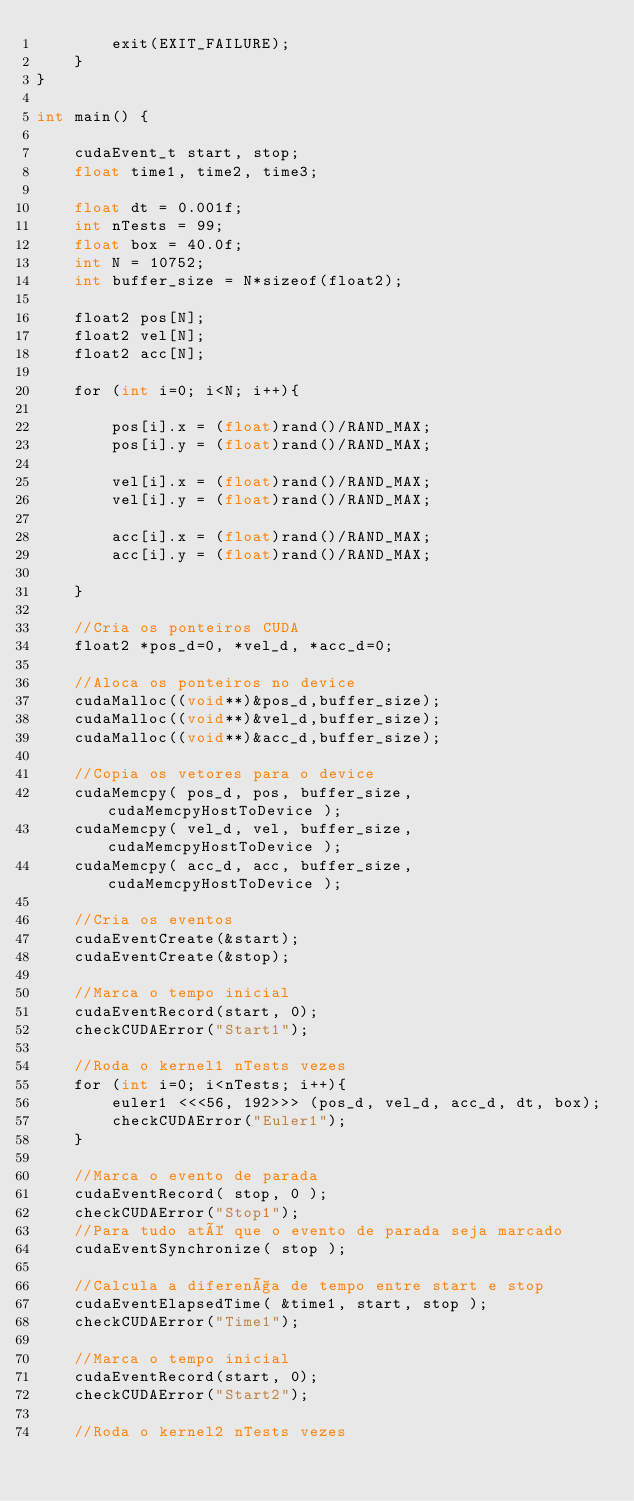Convert code to text. <code><loc_0><loc_0><loc_500><loc_500><_Cuda_>        exit(EXIT_FAILURE);
    }                         
}

int main() {

	cudaEvent_t start, stop;
	float time1, time2, time3;

	float dt = 0.001f;	
	int nTests = 99;
	float box = 40.0f;
	int N = 10752;
	int buffer_size = N*sizeof(float2);

	float2 pos[N];
	float2 vel[N];
	float2 acc[N];

	for (int i=0; i<N; i++){

		pos[i].x = (float)rand()/RAND_MAX;
		pos[i].y = (float)rand()/RAND_MAX;

		vel[i].x = (float)rand()/RAND_MAX;
		vel[i].y = (float)rand()/RAND_MAX;

		acc[i].x = (float)rand()/RAND_MAX;
		acc[i].y = (float)rand()/RAND_MAX;

	}
	
	//Cria os ponteiros CUDA	
	float2 *pos_d=0, *vel_d, *acc_d=0;
	
	//Aloca os ponteiros no device
	cudaMalloc((void**)&pos_d,buffer_size);
	cudaMalloc((void**)&vel_d,buffer_size);
	cudaMalloc((void**)&acc_d,buffer_size);
	
	//Copia os vetores para o device		
	cudaMemcpy( pos_d, pos, buffer_size, cudaMemcpyHostToDevice );
	cudaMemcpy( vel_d, vel, buffer_size, cudaMemcpyHostToDevice );
	cudaMemcpy( acc_d, acc, buffer_size, cudaMemcpyHostToDevice );

	//Cria os eventos
	cudaEventCreate(&start);
	cudaEventCreate(&stop);

	//Marca o tempo inicial
	cudaEventRecord(start, 0);
	checkCUDAError("Start1");

	//Roda o kernel1 nTests vezes	
	for (int i=0; i<nTests; i++){
		euler1 <<<56, 192>>> (pos_d, vel_d, acc_d, dt, box);
		checkCUDAError("Euler1");
	}

	//Marca o evento de parada
	cudaEventRecord( stop, 0 );
	checkCUDAError("Stop1");
	//Para tudo até que o evento de parada seja marcado
	cudaEventSynchronize( stop );

	//Calcula a diferença de tempo entre start e stop
	cudaEventElapsedTime( &time1, start, stop );
	checkCUDAError("Time1");

	//Marca o tempo inicial
	cudaEventRecord(start, 0);
	checkCUDAError("Start2");	

	//Roda o kernel2 nTests vezes	</code> 